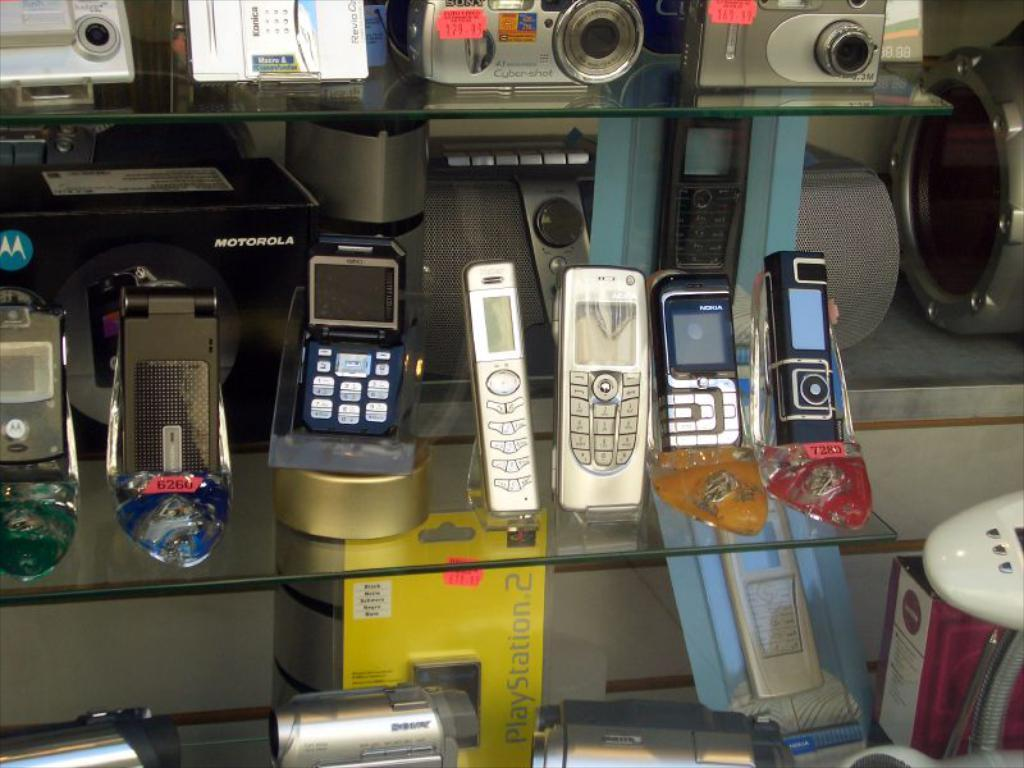<image>
Share a concise interpretation of the image provided. Cellphones being put on display with a yellow box that says Playstation 2. 